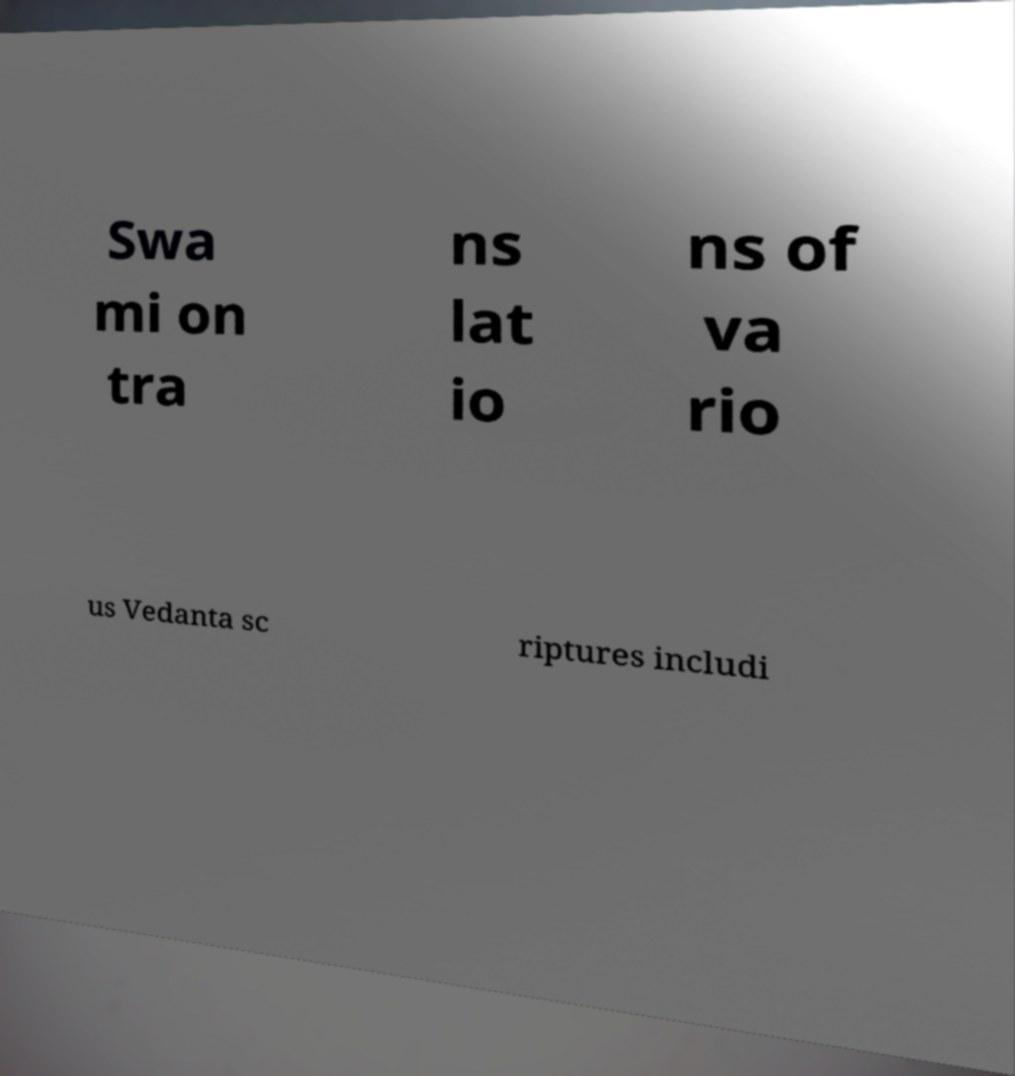There's text embedded in this image that I need extracted. Can you transcribe it verbatim? Swa mi on tra ns lat io ns of va rio us Vedanta sc riptures includi 